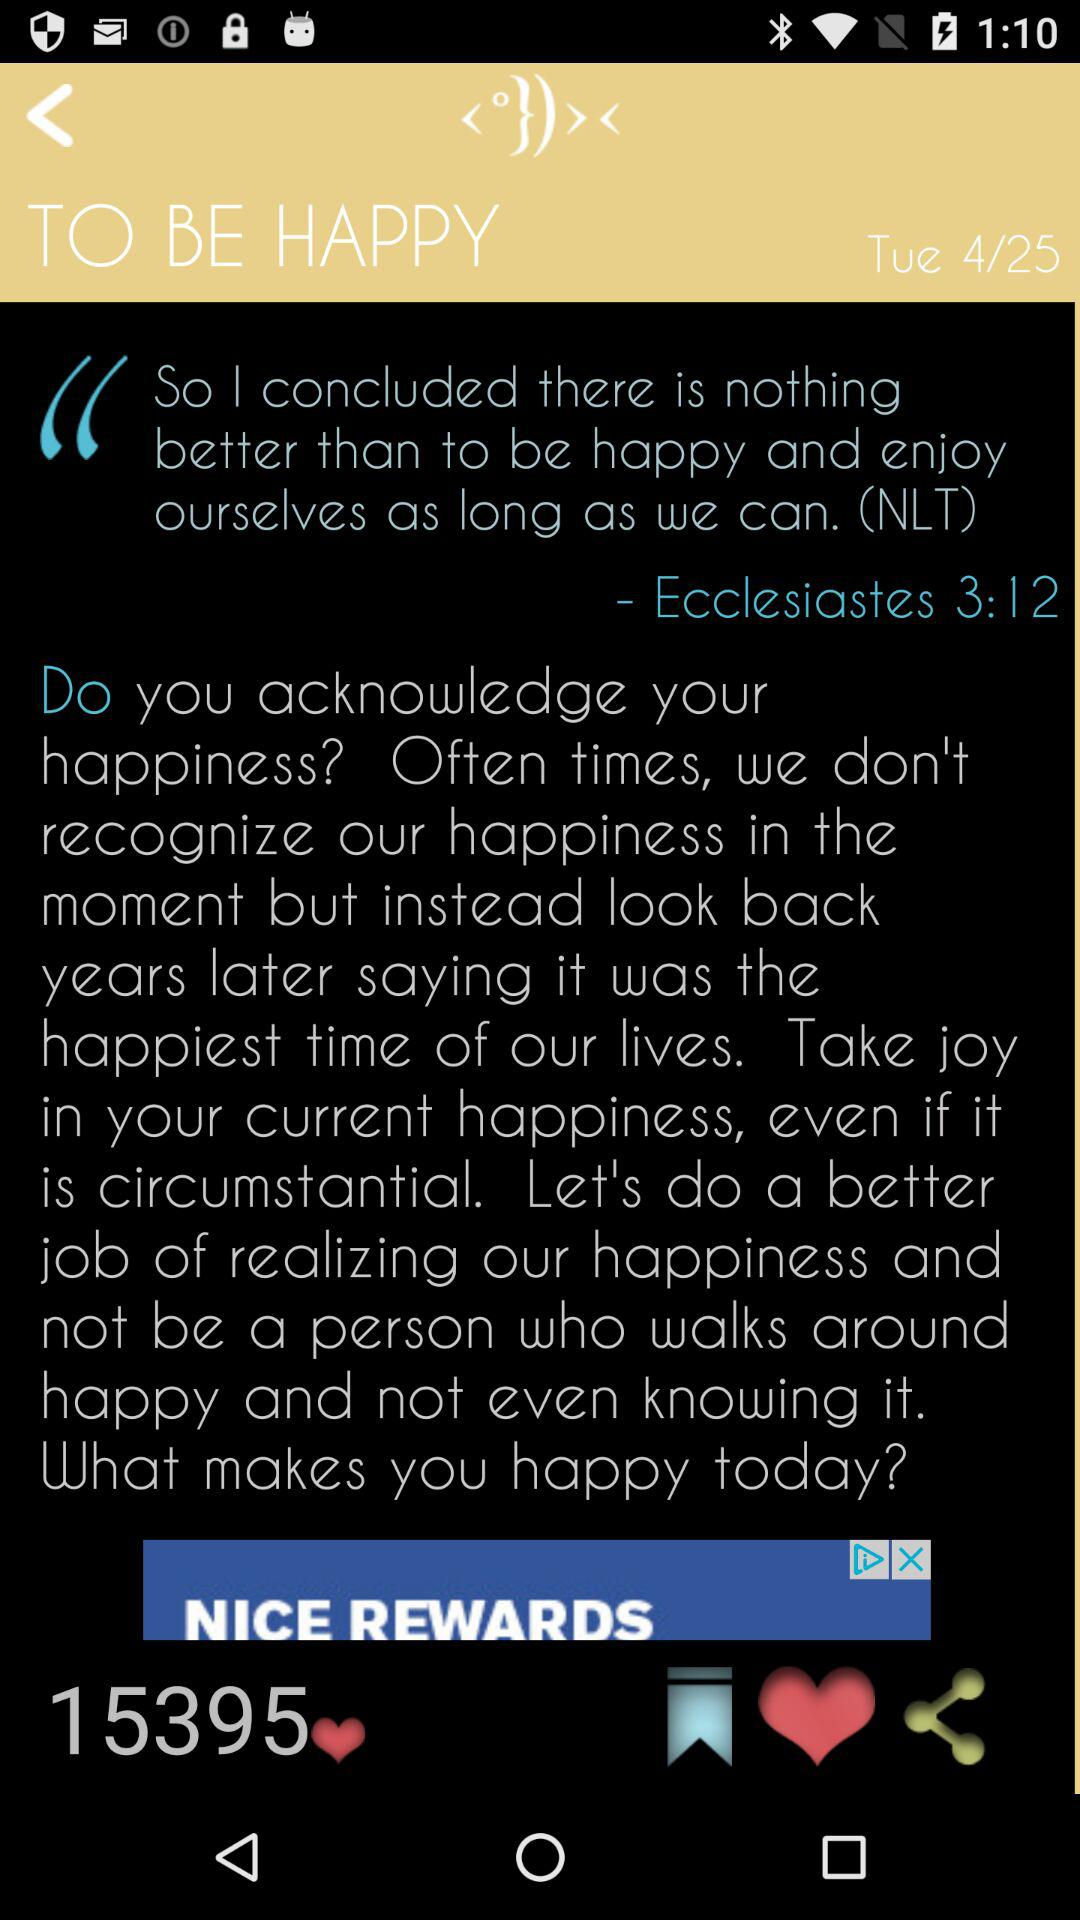What is the day? The day is Tuesday. 